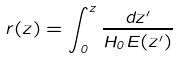<formula> <loc_0><loc_0><loc_500><loc_500>r ( z ) = \int _ { 0 } ^ { z } \frac { d z ^ { \prime } } { H _ { 0 } E ( z ^ { \prime } ) }</formula> 